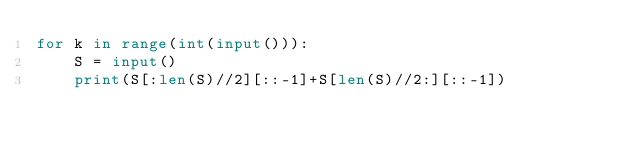<code> <loc_0><loc_0><loc_500><loc_500><_Python_>for k in range(int(input())):
    S = input()
    print(S[:len(S)//2][::-1]+S[len(S)//2:][::-1])
</code> 